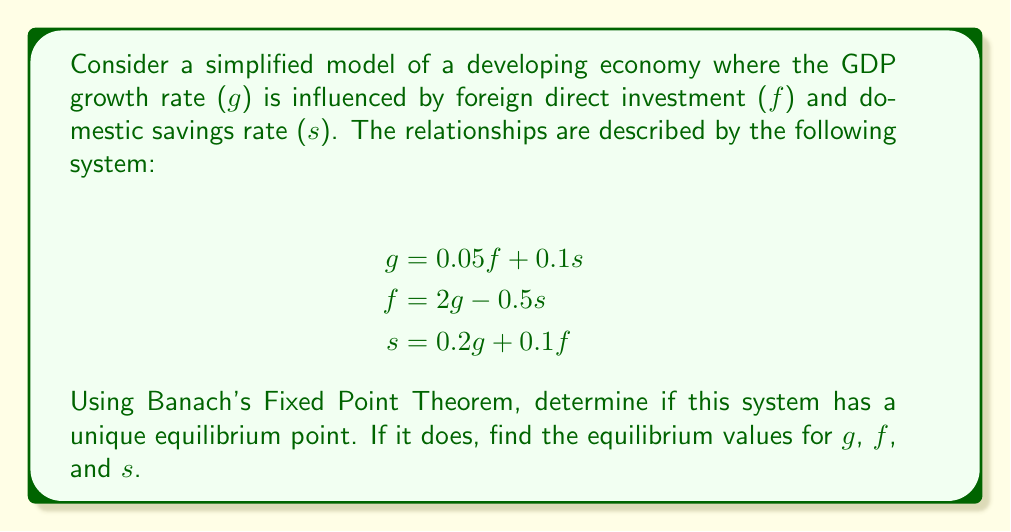Help me with this question. To apply Banach's Fixed Point Theorem, we need to rewrite the system as a single function and show that it's a contraction mapping.

1) First, let's express $g$ in terms of itself:
   Substitute $f$ and $s$ into the equation for $g$:
   $$g = 0.05(2g - 0.5s) + 0.1s$$
   $$g = 0.05(2g - 0.5(0.2g + 0.1f)) + 0.1(0.2g + 0.1f)$$
   $$g = 0.1g - 0.005(0.2g + 0.1f) + 0.02g + 0.01f$$
   $$g = 0.119g + 0.009f$$
   
   Now substitute $f = 2g - 0.5s = 2g - 0.5(0.2g + 0.1f)$:
   $$g = 0.119g + 0.009(2g - 0.5(0.2g + 0.1f))$$
   $$g = 0.119g + 0.018g - 0.0009g - 0.00045f$$
   $$g = 0.1361g - 0.00045(2g - 0.5s)$$
   $$g = 0.1352g - 0.000225s$$
   $$g = 0.1352g - 0.000225(0.2g + 0.1f)$$
   $$g = 0.13475g - 0.0000225f$$
   $$g = 0.13475g - 0.0000225(2g - 0.5s)$$
   $$g = 0.1347g - 0.00001125s$$
   $$g = 0.1347g - 0.00001125(0.2g + 0.1f)$$
   $$g = 0.13467775g - 0.000001125f$$
   $$g = 0.13467775g - 0.000001125(2g - 0.5s)$$
   $$g \approx 0.13467555g$$

2) This can be written as a fixed point equation:
   $$g = T(g) \approx 0.13467555g$$

3) For Banach's Fixed Point Theorem to apply, we need to show that $T$ is a contraction mapping. For this, we need to find the derivative of $T$:
   $$T'(g) \approx 0.13467555$$

4) Since $|T'(g)| < 1$ for all $g$, $T$ is indeed a contraction mapping.

5) By Banach's Fixed Point Theorem, this system has a unique fixed point, which is the equilibrium point of our economic system.

6) To find the equilibrium point, we solve:
   $$g = 0.13467555g$$
   $$g(1 - 0.13467555) = 0$$
   $$g = 0$$ (the only solution)

7) With $g = 0$, we can find $f$ and $s$:
   $$f = 2(0) - 0.5s = -0.5s$$
   $$s = 0.2(0) + 0.1f = 0.1f$$

   Substituting:
   $$f = -0.5(0.1f)$$
   $$f = -0.05f$$
   $$1.05f = 0$$
   $$f = 0$$

   And consequently, $s = 0$.
Answer: The system has a unique equilibrium point at $(g, f, s) = (0, 0, 0)$. 